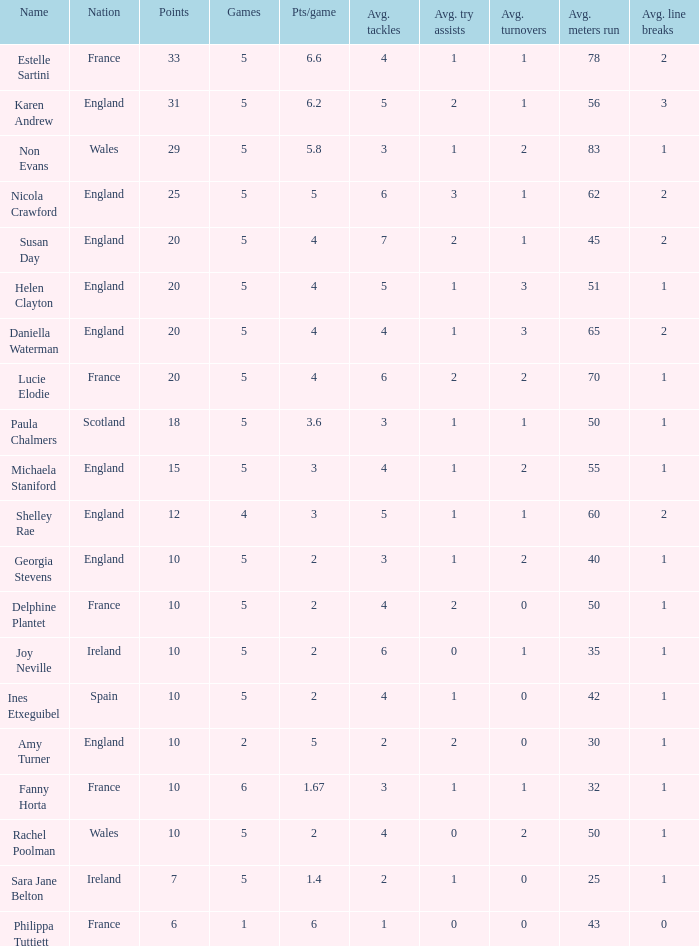Can you tell me the average Points that has a Pts/game larger than 4, and the Nation of england, and the Games smaller than 5? 10.0. 